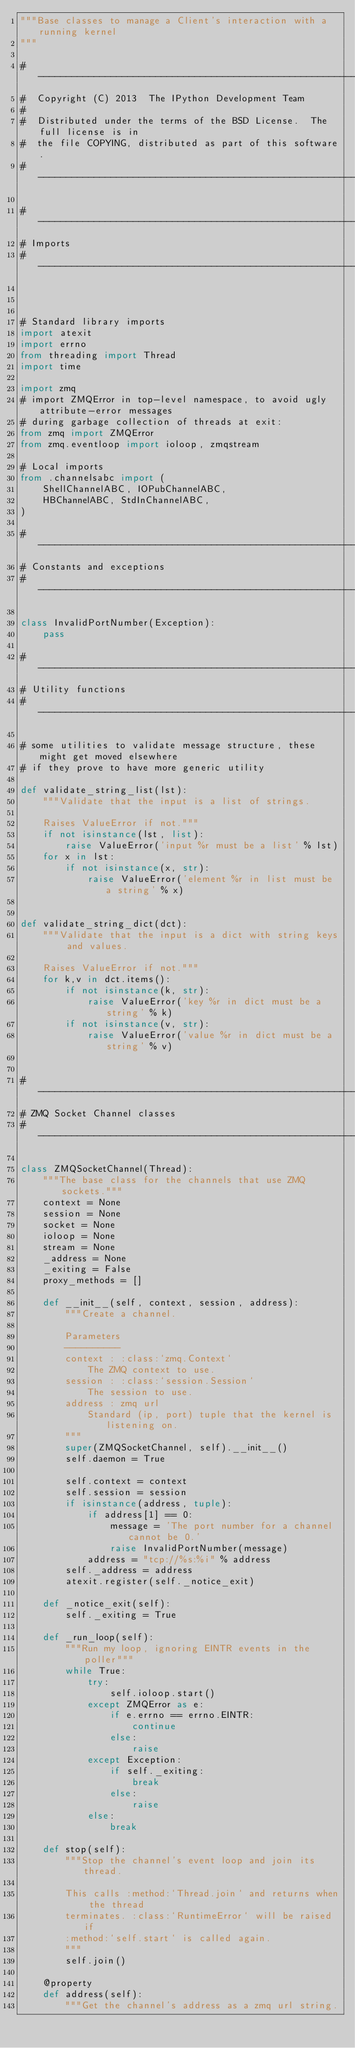<code> <loc_0><loc_0><loc_500><loc_500><_Python_>"""Base classes to manage a Client's interaction with a running kernel
"""

#-----------------------------------------------------------------------------
#  Copyright (C) 2013  The IPython Development Team
#
#  Distributed under the terms of the BSD License.  The full license is in
#  the file COPYING, distributed as part of this software.
#-----------------------------------------------------------------------------

#-----------------------------------------------------------------------------
# Imports
#-----------------------------------------------------------------------------



# Standard library imports
import atexit
import errno
from threading import Thread
import time

import zmq
# import ZMQError in top-level namespace, to avoid ugly attribute-error messages
# during garbage collection of threads at exit:
from zmq import ZMQError
from zmq.eventloop import ioloop, zmqstream

# Local imports
from .channelsabc import (
    ShellChannelABC, IOPubChannelABC,
    HBChannelABC, StdInChannelABC,
)

#-----------------------------------------------------------------------------
# Constants and exceptions
#-----------------------------------------------------------------------------

class InvalidPortNumber(Exception):
    pass

#-----------------------------------------------------------------------------
# Utility functions
#-----------------------------------------------------------------------------

# some utilities to validate message structure, these might get moved elsewhere
# if they prove to have more generic utility

def validate_string_list(lst):
    """Validate that the input is a list of strings.

    Raises ValueError if not."""
    if not isinstance(lst, list):
        raise ValueError('input %r must be a list' % lst)
    for x in lst:
        if not isinstance(x, str):
            raise ValueError('element %r in list must be a string' % x)


def validate_string_dict(dct):
    """Validate that the input is a dict with string keys and values.

    Raises ValueError if not."""
    for k,v in dct.items():
        if not isinstance(k, str):
            raise ValueError('key %r in dict must be a string' % k)
        if not isinstance(v, str):
            raise ValueError('value %r in dict must be a string' % v)


#-----------------------------------------------------------------------------
# ZMQ Socket Channel classes
#-----------------------------------------------------------------------------

class ZMQSocketChannel(Thread):
    """The base class for the channels that use ZMQ sockets."""
    context = None
    session = None
    socket = None
    ioloop = None
    stream = None
    _address = None
    _exiting = False
    proxy_methods = []

    def __init__(self, context, session, address):
        """Create a channel.

        Parameters
        ----------
        context : :class:`zmq.Context`
            The ZMQ context to use.
        session : :class:`session.Session`
            The session to use.
        address : zmq url
            Standard (ip, port) tuple that the kernel is listening on.
        """
        super(ZMQSocketChannel, self).__init__()
        self.daemon = True

        self.context = context
        self.session = session
        if isinstance(address, tuple):
            if address[1] == 0:
                message = 'The port number for a channel cannot be 0.'
                raise InvalidPortNumber(message)
            address = "tcp://%s:%i" % address
        self._address = address
        atexit.register(self._notice_exit)

    def _notice_exit(self):
        self._exiting = True

    def _run_loop(self):
        """Run my loop, ignoring EINTR events in the poller"""
        while True:
            try:
                self.ioloop.start()
            except ZMQError as e:
                if e.errno == errno.EINTR:
                    continue
                else:
                    raise
            except Exception:
                if self._exiting:
                    break
                else:
                    raise
            else:
                break

    def stop(self):
        """Stop the channel's event loop and join its thread.

        This calls :method:`Thread.join` and returns when the thread
        terminates. :class:`RuntimeError` will be raised if
        :method:`self.start` is called again.
        """
        self.join()

    @property
    def address(self):
        """Get the channel's address as a zmq url string.
</code> 